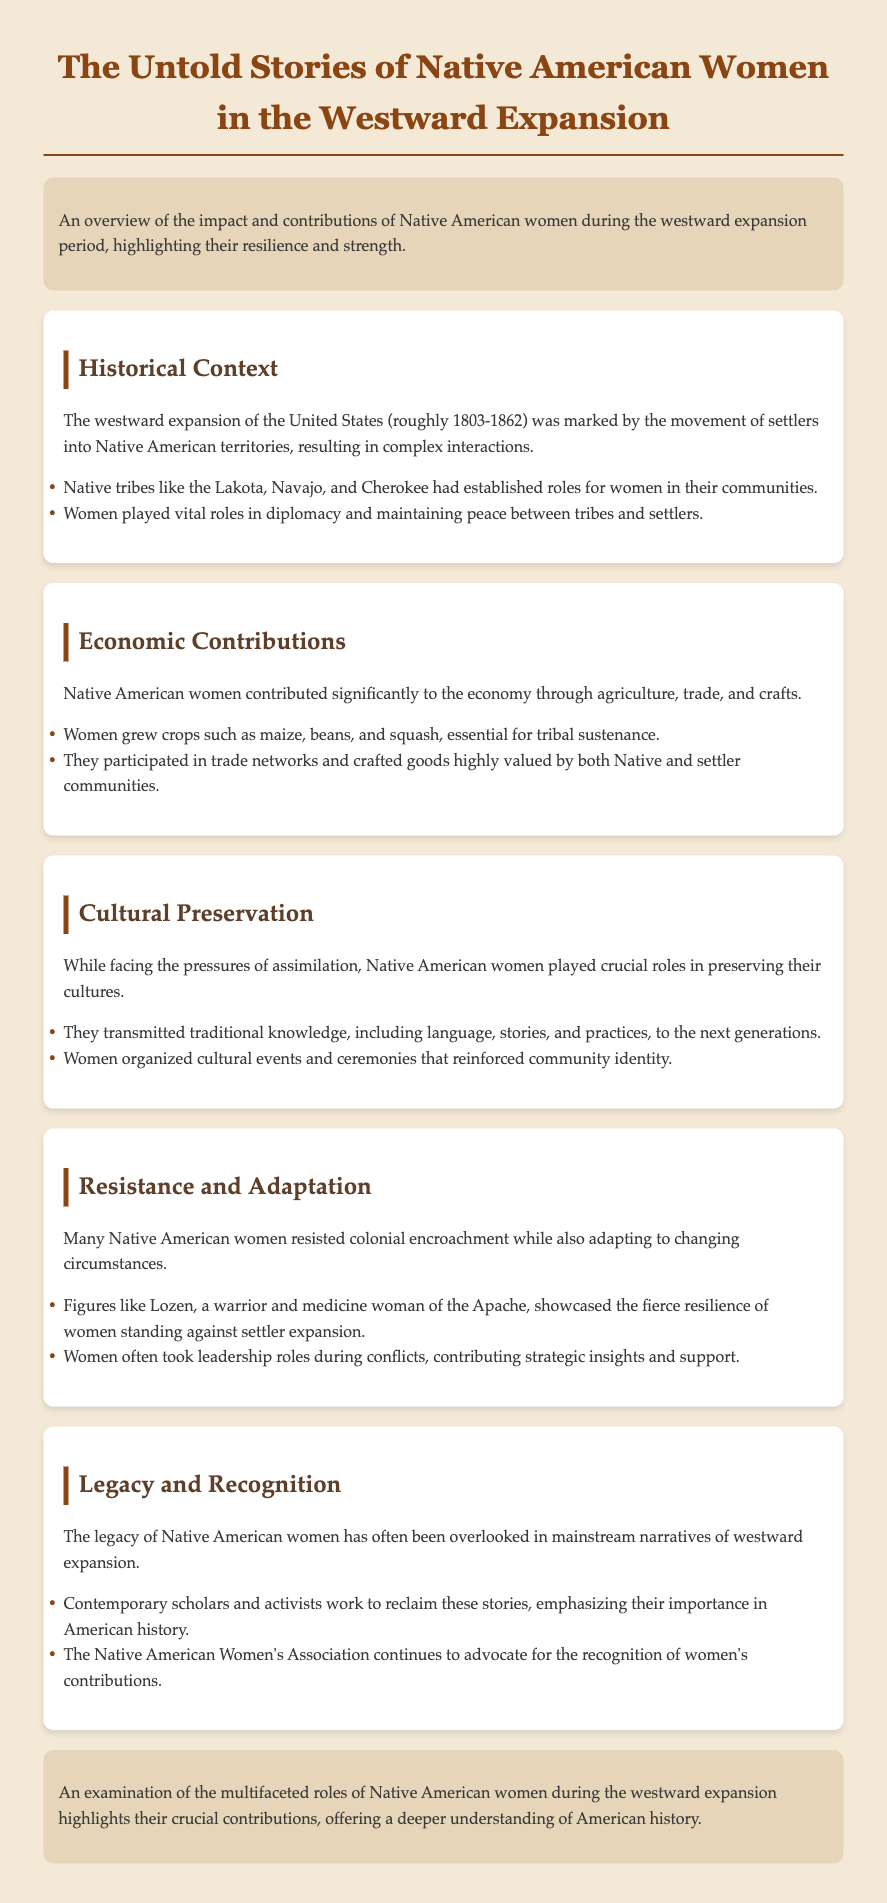What was the time frame of the westward expansion? The document states that the westward expansion occurred roughly from 1803 to 1862.
Answer: 1803-1862 Which tribes are mentioned in the historical context? The document lists the Lakota, Navajo, and Cherokee as tribes during this period.
Answer: Lakota, Navajo, Cherokee What crops did Native American women grow? It specifies that women grew maize, beans, and squash, which were essential for sustenance.
Answer: Maize, beans, squash Who was Lozen? The document describes Lozen as a warrior and medicine woman of the Apache.
Answer: Warrior and medicine woman What is one role of Native American women in cultural preservation? The document mentions that women transmitted traditional knowledge including language, stories, and practices.
Answer: Transmitting traditional knowledge What organization advocates for the recognition of Native American women's contributions? The Native American Women's Association is mentioned as advocating for women's contributions.
Answer: Native American Women's Association Why is the legacy of Native American women often overlooked? The document indicates that their contributions have been largely absent in mainstream narratives of westward expansion.
Answer: Overlooked in mainstream narratives What type of resistance did Native American women exhibit? The document states many resisted colonial encroachment while adapting to changing circumstances.
Answer: Resisted colonial encroachment What is emphasized in the conclusion about Native American women's roles? The conclusion highlights their multifaceted roles and crucial contributions to understanding American history.
Answer: Crucial contributions 